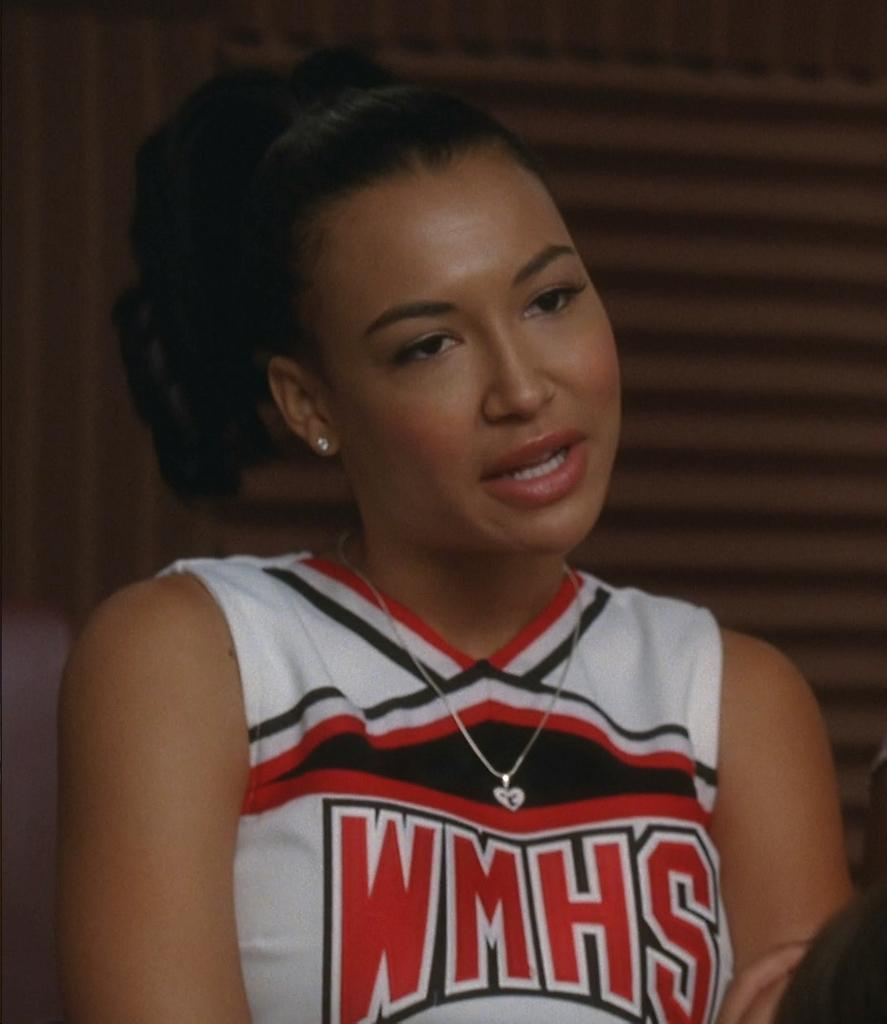<image>
Create a compact narrative representing the image presented. cheerleader wearing hear necklace and has wmhs on her top 